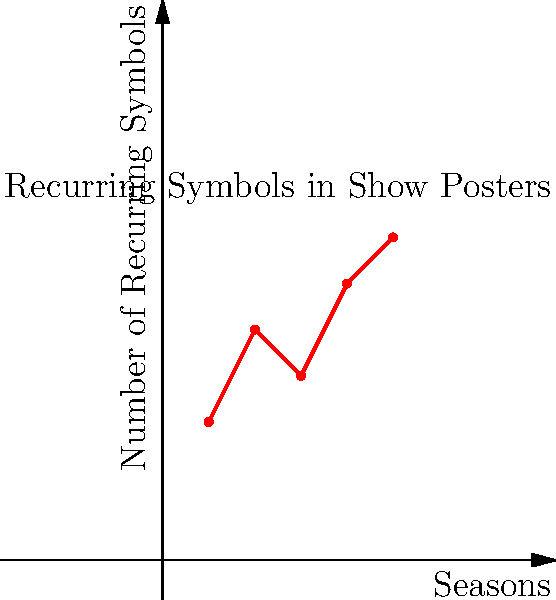Hey bro, I bet you can't tell me how many recurring symbols appeared in the show's posters for Season 2. Can you prove me wrong, or are you too busy rewatching that silly show for the millionth time? Let's break this down step-by-step:

1. The graph shows the number of recurring symbols in show posters across 5 seasons.
2. The x-axis represents the seasons, while the y-axis represents the number of recurring symbols.
3. To find the number of symbols for Season 2, we need to look at the data point corresponding to x = 2 on the graph.
4. Following the vertical line from x = 2, we can see it intersects with a red dot.
5. From this dot, if we trace horizontally to the y-axis, we can see it aligns with the value 5.

Therefore, in Season 2, there were 5 recurring symbols in the show's posters.
Answer: 5 symbols 